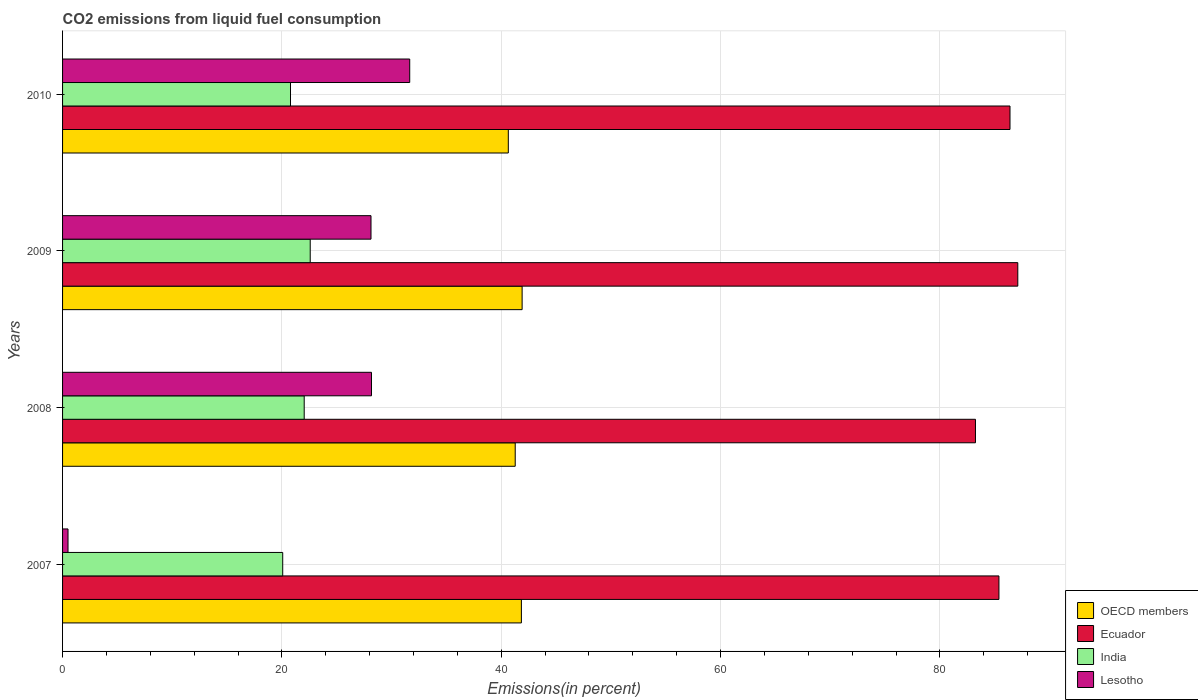How many different coloured bars are there?
Provide a short and direct response. 4. Are the number of bars on each tick of the Y-axis equal?
Your response must be concise. Yes. In how many cases, is the number of bars for a given year not equal to the number of legend labels?
Your response must be concise. 0. What is the total CO2 emitted in Lesotho in 2009?
Offer a very short reply. 28.12. Across all years, what is the maximum total CO2 emitted in Lesotho?
Your response must be concise. 31.66. Across all years, what is the minimum total CO2 emitted in Ecuador?
Give a very brief answer. 83.24. In which year was the total CO2 emitted in India maximum?
Offer a terse response. 2009. What is the total total CO2 emitted in Ecuador in the graph?
Ensure brevity in your answer.  342.12. What is the difference between the total CO2 emitted in Lesotho in 2007 and that in 2009?
Your answer should be very brief. -27.63. What is the difference between the total CO2 emitted in Lesotho in 2008 and the total CO2 emitted in India in 2007?
Provide a short and direct response. 8.09. What is the average total CO2 emitted in Lesotho per year?
Your answer should be very brief. 22.11. In the year 2007, what is the difference between the total CO2 emitted in India and total CO2 emitted in OECD members?
Keep it short and to the point. -21.76. What is the ratio of the total CO2 emitted in OECD members in 2007 to that in 2009?
Provide a short and direct response. 1. Is the difference between the total CO2 emitted in India in 2007 and 2010 greater than the difference between the total CO2 emitted in OECD members in 2007 and 2010?
Offer a very short reply. No. What is the difference between the highest and the second highest total CO2 emitted in OECD members?
Offer a terse response. 0.07. What is the difference between the highest and the lowest total CO2 emitted in OECD members?
Ensure brevity in your answer.  1.26. What does the 4th bar from the bottom in 2007 represents?
Provide a succinct answer. Lesotho. How many years are there in the graph?
Provide a short and direct response. 4. Does the graph contain any zero values?
Your answer should be very brief. No. Does the graph contain grids?
Offer a terse response. Yes. What is the title of the graph?
Keep it short and to the point. CO2 emissions from liquid fuel consumption. Does "Puerto Rico" appear as one of the legend labels in the graph?
Provide a short and direct response. No. What is the label or title of the X-axis?
Make the answer very short. Emissions(in percent). What is the label or title of the Y-axis?
Your response must be concise. Years. What is the Emissions(in percent) of OECD members in 2007?
Your answer should be very brief. 41.84. What is the Emissions(in percent) in Ecuador in 2007?
Your answer should be compact. 85.38. What is the Emissions(in percent) of India in 2007?
Your answer should be very brief. 20.08. What is the Emissions(in percent) in Lesotho in 2007?
Provide a succinct answer. 0.5. What is the Emissions(in percent) of OECD members in 2008?
Offer a terse response. 41.27. What is the Emissions(in percent) in Ecuador in 2008?
Offer a very short reply. 83.24. What is the Emissions(in percent) in India in 2008?
Give a very brief answer. 22.03. What is the Emissions(in percent) of Lesotho in 2008?
Provide a short and direct response. 28.17. What is the Emissions(in percent) of OECD members in 2009?
Ensure brevity in your answer.  41.9. What is the Emissions(in percent) of Ecuador in 2009?
Offer a terse response. 87.1. What is the Emissions(in percent) in India in 2009?
Your answer should be very brief. 22.58. What is the Emissions(in percent) in Lesotho in 2009?
Your answer should be very brief. 28.12. What is the Emissions(in percent) in OECD members in 2010?
Provide a short and direct response. 40.64. What is the Emissions(in percent) in Ecuador in 2010?
Your answer should be compact. 86.39. What is the Emissions(in percent) of India in 2010?
Give a very brief answer. 20.78. What is the Emissions(in percent) of Lesotho in 2010?
Give a very brief answer. 31.66. Across all years, what is the maximum Emissions(in percent) of OECD members?
Give a very brief answer. 41.9. Across all years, what is the maximum Emissions(in percent) of Ecuador?
Offer a terse response. 87.1. Across all years, what is the maximum Emissions(in percent) in India?
Offer a terse response. 22.58. Across all years, what is the maximum Emissions(in percent) of Lesotho?
Your answer should be compact. 31.66. Across all years, what is the minimum Emissions(in percent) of OECD members?
Your response must be concise. 40.64. Across all years, what is the minimum Emissions(in percent) of Ecuador?
Ensure brevity in your answer.  83.24. Across all years, what is the minimum Emissions(in percent) in India?
Your response must be concise. 20.08. Across all years, what is the minimum Emissions(in percent) of Lesotho?
Offer a very short reply. 0.5. What is the total Emissions(in percent) in OECD members in the graph?
Your answer should be compact. 165.66. What is the total Emissions(in percent) of Ecuador in the graph?
Keep it short and to the point. 342.12. What is the total Emissions(in percent) in India in the graph?
Make the answer very short. 85.47. What is the total Emissions(in percent) of Lesotho in the graph?
Provide a succinct answer. 88.45. What is the difference between the Emissions(in percent) of OECD members in 2007 and that in 2008?
Make the answer very short. 0.56. What is the difference between the Emissions(in percent) in Ecuador in 2007 and that in 2008?
Provide a short and direct response. 2.14. What is the difference between the Emissions(in percent) of India in 2007 and that in 2008?
Offer a very short reply. -1.96. What is the difference between the Emissions(in percent) of Lesotho in 2007 and that in 2008?
Your answer should be compact. -27.67. What is the difference between the Emissions(in percent) in OECD members in 2007 and that in 2009?
Provide a short and direct response. -0.07. What is the difference between the Emissions(in percent) in Ecuador in 2007 and that in 2009?
Your response must be concise. -1.72. What is the difference between the Emissions(in percent) of India in 2007 and that in 2009?
Make the answer very short. -2.51. What is the difference between the Emissions(in percent) in Lesotho in 2007 and that in 2009?
Your answer should be very brief. -27.63. What is the difference between the Emissions(in percent) of OECD members in 2007 and that in 2010?
Ensure brevity in your answer.  1.19. What is the difference between the Emissions(in percent) of Ecuador in 2007 and that in 2010?
Provide a short and direct response. -1.01. What is the difference between the Emissions(in percent) of India in 2007 and that in 2010?
Offer a terse response. -0.71. What is the difference between the Emissions(in percent) in Lesotho in 2007 and that in 2010?
Your answer should be compact. -31.16. What is the difference between the Emissions(in percent) of OECD members in 2008 and that in 2009?
Your response must be concise. -0.63. What is the difference between the Emissions(in percent) in Ecuador in 2008 and that in 2009?
Give a very brief answer. -3.86. What is the difference between the Emissions(in percent) of India in 2008 and that in 2009?
Your answer should be compact. -0.55. What is the difference between the Emissions(in percent) of Lesotho in 2008 and that in 2009?
Your response must be concise. 0.04. What is the difference between the Emissions(in percent) of OECD members in 2008 and that in 2010?
Make the answer very short. 0.63. What is the difference between the Emissions(in percent) in Ecuador in 2008 and that in 2010?
Ensure brevity in your answer.  -3.15. What is the difference between the Emissions(in percent) of India in 2008 and that in 2010?
Ensure brevity in your answer.  1.25. What is the difference between the Emissions(in percent) in Lesotho in 2008 and that in 2010?
Provide a short and direct response. -3.49. What is the difference between the Emissions(in percent) of OECD members in 2009 and that in 2010?
Give a very brief answer. 1.26. What is the difference between the Emissions(in percent) in Ecuador in 2009 and that in 2010?
Give a very brief answer. 0.71. What is the difference between the Emissions(in percent) of India in 2009 and that in 2010?
Offer a very short reply. 1.8. What is the difference between the Emissions(in percent) of Lesotho in 2009 and that in 2010?
Ensure brevity in your answer.  -3.53. What is the difference between the Emissions(in percent) in OECD members in 2007 and the Emissions(in percent) in Ecuador in 2008?
Give a very brief answer. -41.41. What is the difference between the Emissions(in percent) of OECD members in 2007 and the Emissions(in percent) of India in 2008?
Provide a succinct answer. 19.8. What is the difference between the Emissions(in percent) in OECD members in 2007 and the Emissions(in percent) in Lesotho in 2008?
Your answer should be very brief. 13.67. What is the difference between the Emissions(in percent) of Ecuador in 2007 and the Emissions(in percent) of India in 2008?
Keep it short and to the point. 63.35. What is the difference between the Emissions(in percent) of Ecuador in 2007 and the Emissions(in percent) of Lesotho in 2008?
Ensure brevity in your answer.  57.21. What is the difference between the Emissions(in percent) of India in 2007 and the Emissions(in percent) of Lesotho in 2008?
Your answer should be very brief. -8.09. What is the difference between the Emissions(in percent) of OECD members in 2007 and the Emissions(in percent) of Ecuador in 2009?
Your answer should be compact. -45.26. What is the difference between the Emissions(in percent) in OECD members in 2007 and the Emissions(in percent) in India in 2009?
Offer a terse response. 19.26. What is the difference between the Emissions(in percent) in OECD members in 2007 and the Emissions(in percent) in Lesotho in 2009?
Keep it short and to the point. 13.71. What is the difference between the Emissions(in percent) of Ecuador in 2007 and the Emissions(in percent) of India in 2009?
Your answer should be very brief. 62.8. What is the difference between the Emissions(in percent) of Ecuador in 2007 and the Emissions(in percent) of Lesotho in 2009?
Provide a succinct answer. 57.26. What is the difference between the Emissions(in percent) of India in 2007 and the Emissions(in percent) of Lesotho in 2009?
Provide a succinct answer. -8.05. What is the difference between the Emissions(in percent) in OECD members in 2007 and the Emissions(in percent) in Ecuador in 2010?
Your response must be concise. -44.55. What is the difference between the Emissions(in percent) of OECD members in 2007 and the Emissions(in percent) of India in 2010?
Make the answer very short. 21.05. What is the difference between the Emissions(in percent) in OECD members in 2007 and the Emissions(in percent) in Lesotho in 2010?
Give a very brief answer. 10.18. What is the difference between the Emissions(in percent) in Ecuador in 2007 and the Emissions(in percent) in India in 2010?
Make the answer very short. 64.6. What is the difference between the Emissions(in percent) of Ecuador in 2007 and the Emissions(in percent) of Lesotho in 2010?
Your answer should be very brief. 53.73. What is the difference between the Emissions(in percent) in India in 2007 and the Emissions(in percent) in Lesotho in 2010?
Give a very brief answer. -11.58. What is the difference between the Emissions(in percent) of OECD members in 2008 and the Emissions(in percent) of Ecuador in 2009?
Offer a very short reply. -45.83. What is the difference between the Emissions(in percent) in OECD members in 2008 and the Emissions(in percent) in India in 2009?
Provide a succinct answer. 18.69. What is the difference between the Emissions(in percent) of OECD members in 2008 and the Emissions(in percent) of Lesotho in 2009?
Offer a terse response. 13.15. What is the difference between the Emissions(in percent) of Ecuador in 2008 and the Emissions(in percent) of India in 2009?
Offer a very short reply. 60.66. What is the difference between the Emissions(in percent) in Ecuador in 2008 and the Emissions(in percent) in Lesotho in 2009?
Ensure brevity in your answer.  55.12. What is the difference between the Emissions(in percent) in India in 2008 and the Emissions(in percent) in Lesotho in 2009?
Provide a succinct answer. -6.09. What is the difference between the Emissions(in percent) of OECD members in 2008 and the Emissions(in percent) of Ecuador in 2010?
Your response must be concise. -45.12. What is the difference between the Emissions(in percent) of OECD members in 2008 and the Emissions(in percent) of India in 2010?
Ensure brevity in your answer.  20.49. What is the difference between the Emissions(in percent) in OECD members in 2008 and the Emissions(in percent) in Lesotho in 2010?
Your response must be concise. 9.62. What is the difference between the Emissions(in percent) of Ecuador in 2008 and the Emissions(in percent) of India in 2010?
Your answer should be compact. 62.46. What is the difference between the Emissions(in percent) in Ecuador in 2008 and the Emissions(in percent) in Lesotho in 2010?
Offer a very short reply. 51.59. What is the difference between the Emissions(in percent) in India in 2008 and the Emissions(in percent) in Lesotho in 2010?
Your response must be concise. -9.62. What is the difference between the Emissions(in percent) in OECD members in 2009 and the Emissions(in percent) in Ecuador in 2010?
Ensure brevity in your answer.  -44.49. What is the difference between the Emissions(in percent) in OECD members in 2009 and the Emissions(in percent) in India in 2010?
Offer a very short reply. 21.12. What is the difference between the Emissions(in percent) of OECD members in 2009 and the Emissions(in percent) of Lesotho in 2010?
Provide a short and direct response. 10.25. What is the difference between the Emissions(in percent) of Ecuador in 2009 and the Emissions(in percent) of India in 2010?
Provide a succinct answer. 66.32. What is the difference between the Emissions(in percent) of Ecuador in 2009 and the Emissions(in percent) of Lesotho in 2010?
Your response must be concise. 55.45. What is the difference between the Emissions(in percent) of India in 2009 and the Emissions(in percent) of Lesotho in 2010?
Your answer should be compact. -9.07. What is the average Emissions(in percent) in OECD members per year?
Your response must be concise. 41.42. What is the average Emissions(in percent) of Ecuador per year?
Give a very brief answer. 85.53. What is the average Emissions(in percent) in India per year?
Your answer should be compact. 21.37. What is the average Emissions(in percent) of Lesotho per year?
Keep it short and to the point. 22.11. In the year 2007, what is the difference between the Emissions(in percent) in OECD members and Emissions(in percent) in Ecuador?
Keep it short and to the point. -43.55. In the year 2007, what is the difference between the Emissions(in percent) in OECD members and Emissions(in percent) in India?
Ensure brevity in your answer.  21.76. In the year 2007, what is the difference between the Emissions(in percent) of OECD members and Emissions(in percent) of Lesotho?
Provide a short and direct response. 41.34. In the year 2007, what is the difference between the Emissions(in percent) in Ecuador and Emissions(in percent) in India?
Make the answer very short. 65.31. In the year 2007, what is the difference between the Emissions(in percent) of Ecuador and Emissions(in percent) of Lesotho?
Ensure brevity in your answer.  84.89. In the year 2007, what is the difference between the Emissions(in percent) of India and Emissions(in percent) of Lesotho?
Offer a terse response. 19.58. In the year 2008, what is the difference between the Emissions(in percent) of OECD members and Emissions(in percent) of Ecuador?
Give a very brief answer. -41.97. In the year 2008, what is the difference between the Emissions(in percent) of OECD members and Emissions(in percent) of India?
Give a very brief answer. 19.24. In the year 2008, what is the difference between the Emissions(in percent) in OECD members and Emissions(in percent) in Lesotho?
Keep it short and to the point. 13.11. In the year 2008, what is the difference between the Emissions(in percent) of Ecuador and Emissions(in percent) of India?
Keep it short and to the point. 61.21. In the year 2008, what is the difference between the Emissions(in percent) in Ecuador and Emissions(in percent) in Lesotho?
Make the answer very short. 55.07. In the year 2008, what is the difference between the Emissions(in percent) of India and Emissions(in percent) of Lesotho?
Offer a terse response. -6.14. In the year 2009, what is the difference between the Emissions(in percent) in OECD members and Emissions(in percent) in Ecuador?
Offer a terse response. -45.2. In the year 2009, what is the difference between the Emissions(in percent) in OECD members and Emissions(in percent) in India?
Offer a terse response. 19.32. In the year 2009, what is the difference between the Emissions(in percent) of OECD members and Emissions(in percent) of Lesotho?
Keep it short and to the point. 13.78. In the year 2009, what is the difference between the Emissions(in percent) in Ecuador and Emissions(in percent) in India?
Keep it short and to the point. 64.52. In the year 2009, what is the difference between the Emissions(in percent) in Ecuador and Emissions(in percent) in Lesotho?
Your answer should be very brief. 58.98. In the year 2009, what is the difference between the Emissions(in percent) in India and Emissions(in percent) in Lesotho?
Give a very brief answer. -5.54. In the year 2010, what is the difference between the Emissions(in percent) in OECD members and Emissions(in percent) in Ecuador?
Ensure brevity in your answer.  -45.75. In the year 2010, what is the difference between the Emissions(in percent) in OECD members and Emissions(in percent) in India?
Your answer should be compact. 19.86. In the year 2010, what is the difference between the Emissions(in percent) in OECD members and Emissions(in percent) in Lesotho?
Offer a terse response. 8.99. In the year 2010, what is the difference between the Emissions(in percent) of Ecuador and Emissions(in percent) of India?
Ensure brevity in your answer.  65.61. In the year 2010, what is the difference between the Emissions(in percent) in Ecuador and Emissions(in percent) in Lesotho?
Make the answer very short. 54.74. In the year 2010, what is the difference between the Emissions(in percent) in India and Emissions(in percent) in Lesotho?
Offer a terse response. -10.87. What is the ratio of the Emissions(in percent) of OECD members in 2007 to that in 2008?
Provide a short and direct response. 1.01. What is the ratio of the Emissions(in percent) in Ecuador in 2007 to that in 2008?
Your answer should be very brief. 1.03. What is the ratio of the Emissions(in percent) of India in 2007 to that in 2008?
Give a very brief answer. 0.91. What is the ratio of the Emissions(in percent) in Lesotho in 2007 to that in 2008?
Provide a short and direct response. 0.02. What is the ratio of the Emissions(in percent) of OECD members in 2007 to that in 2009?
Provide a succinct answer. 1. What is the ratio of the Emissions(in percent) of Ecuador in 2007 to that in 2009?
Your response must be concise. 0.98. What is the ratio of the Emissions(in percent) of India in 2007 to that in 2009?
Give a very brief answer. 0.89. What is the ratio of the Emissions(in percent) in Lesotho in 2007 to that in 2009?
Offer a very short reply. 0.02. What is the ratio of the Emissions(in percent) of OECD members in 2007 to that in 2010?
Offer a terse response. 1.03. What is the ratio of the Emissions(in percent) in Ecuador in 2007 to that in 2010?
Provide a succinct answer. 0.99. What is the ratio of the Emissions(in percent) of India in 2007 to that in 2010?
Keep it short and to the point. 0.97. What is the ratio of the Emissions(in percent) of Lesotho in 2007 to that in 2010?
Your answer should be compact. 0.02. What is the ratio of the Emissions(in percent) in Ecuador in 2008 to that in 2009?
Offer a very short reply. 0.96. What is the ratio of the Emissions(in percent) in India in 2008 to that in 2009?
Ensure brevity in your answer.  0.98. What is the ratio of the Emissions(in percent) in Lesotho in 2008 to that in 2009?
Offer a very short reply. 1. What is the ratio of the Emissions(in percent) in OECD members in 2008 to that in 2010?
Your answer should be compact. 1.02. What is the ratio of the Emissions(in percent) of Ecuador in 2008 to that in 2010?
Make the answer very short. 0.96. What is the ratio of the Emissions(in percent) in India in 2008 to that in 2010?
Offer a terse response. 1.06. What is the ratio of the Emissions(in percent) in Lesotho in 2008 to that in 2010?
Offer a terse response. 0.89. What is the ratio of the Emissions(in percent) of OECD members in 2009 to that in 2010?
Keep it short and to the point. 1.03. What is the ratio of the Emissions(in percent) of Ecuador in 2009 to that in 2010?
Offer a terse response. 1.01. What is the ratio of the Emissions(in percent) of India in 2009 to that in 2010?
Your answer should be very brief. 1.09. What is the ratio of the Emissions(in percent) in Lesotho in 2009 to that in 2010?
Your answer should be compact. 0.89. What is the difference between the highest and the second highest Emissions(in percent) of OECD members?
Your response must be concise. 0.07. What is the difference between the highest and the second highest Emissions(in percent) in Ecuador?
Make the answer very short. 0.71. What is the difference between the highest and the second highest Emissions(in percent) of India?
Ensure brevity in your answer.  0.55. What is the difference between the highest and the second highest Emissions(in percent) in Lesotho?
Provide a succinct answer. 3.49. What is the difference between the highest and the lowest Emissions(in percent) in OECD members?
Provide a short and direct response. 1.26. What is the difference between the highest and the lowest Emissions(in percent) of Ecuador?
Ensure brevity in your answer.  3.86. What is the difference between the highest and the lowest Emissions(in percent) in India?
Ensure brevity in your answer.  2.51. What is the difference between the highest and the lowest Emissions(in percent) in Lesotho?
Ensure brevity in your answer.  31.16. 